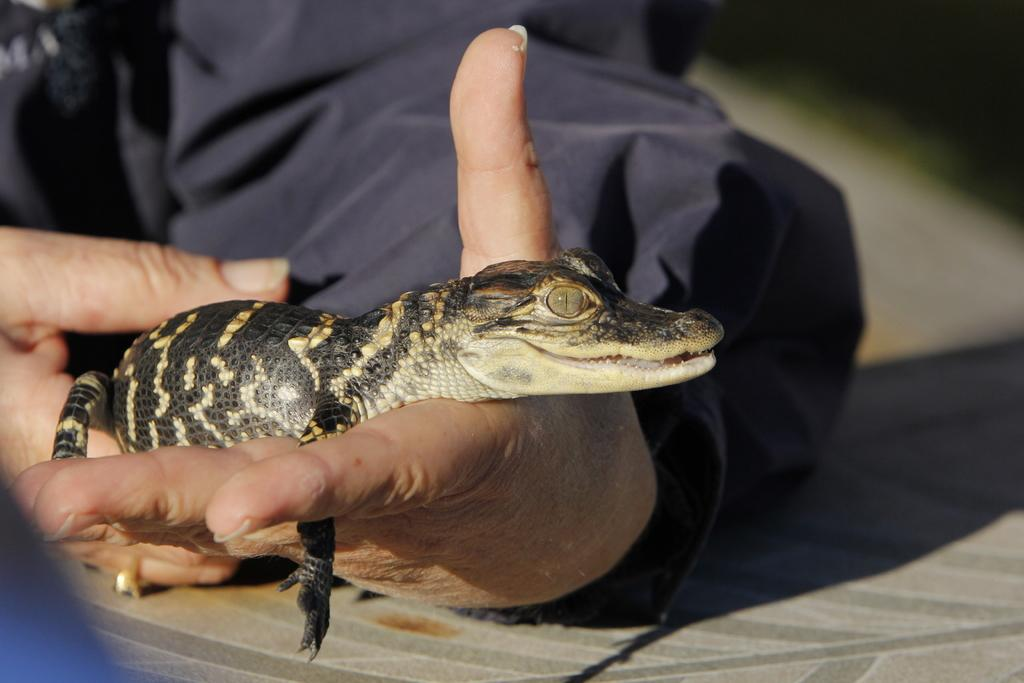What type of animal is in the image? There is a reptile in the image. How is the reptile being held or interacted with? The reptile is on a person's hands. What can be seen on the floor in the image? There is an object on the floor in the image. What type of body part is the reptile using to communicate with the person in the image? Reptiles do not have the ability to communicate using body parts in the same way that humans do, so this question cannot be answered definitively based on the provided facts. Can you tell me how many cables are visible in the image? There is no mention of cables in the provided facts, so it cannot be determined if any cables are visible in the image. 